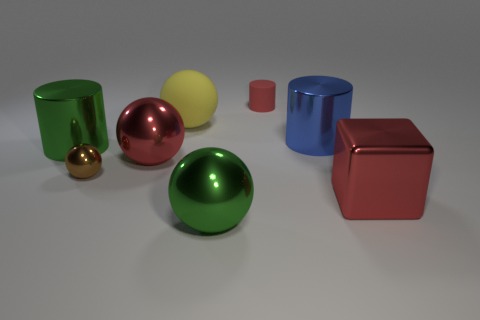There is a large metal object that is the same color as the metal cube; what is its shape?
Your response must be concise. Sphere. There is a large object that is in front of the big metallic cube; is its color the same as the rubber cylinder?
Keep it short and to the point. No. How many brown shiny things are the same size as the red matte thing?
Your answer should be very brief. 1. There is a brown thing that is the same material as the blue thing; what shape is it?
Provide a short and direct response. Sphere. Is there a big metallic ball of the same color as the tiny shiny object?
Your response must be concise. No. What material is the brown object?
Your response must be concise. Metal. What number of objects are either big gray metal objects or metal cylinders?
Your response must be concise. 2. There is a cylinder that is to the left of the yellow sphere; what size is it?
Make the answer very short. Large. What number of other objects are there of the same material as the cube?
Your answer should be very brief. 5. Is there a red sphere that is to the right of the red metal object on the right side of the yellow rubber ball?
Your answer should be compact. No. 